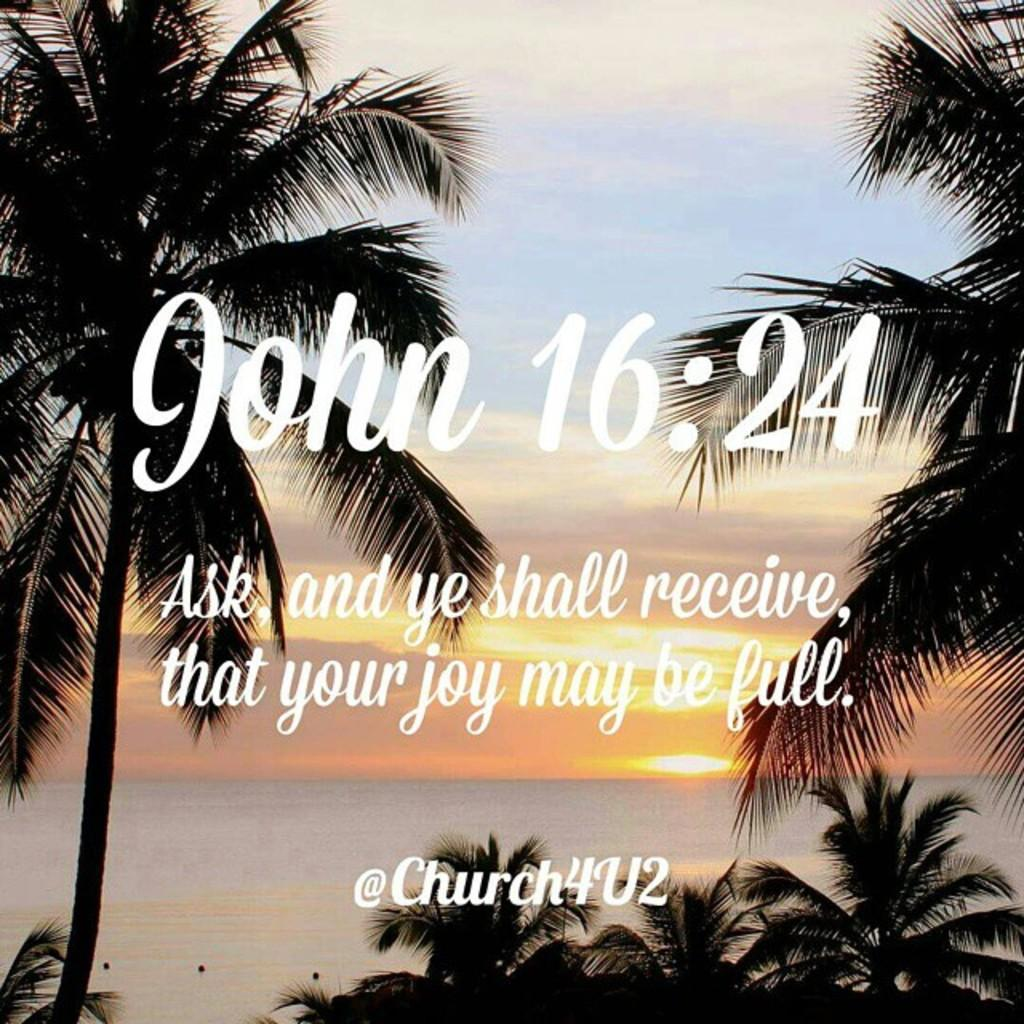What type of natural environment is depicted in the image? There are trees and an ocean in the image, which suggests a coastal or beach setting. What is the condition of the sky in the image? The sky is clear in the image. Is there any text or writing present in the image? Yes, there is text or writing on the image. How many drops of water can be seen falling from the tramp in the image? There is no tramp or water drops present in the image. What type of memory is being stored in the image? The image does not depict any memory storage devices or processes. 